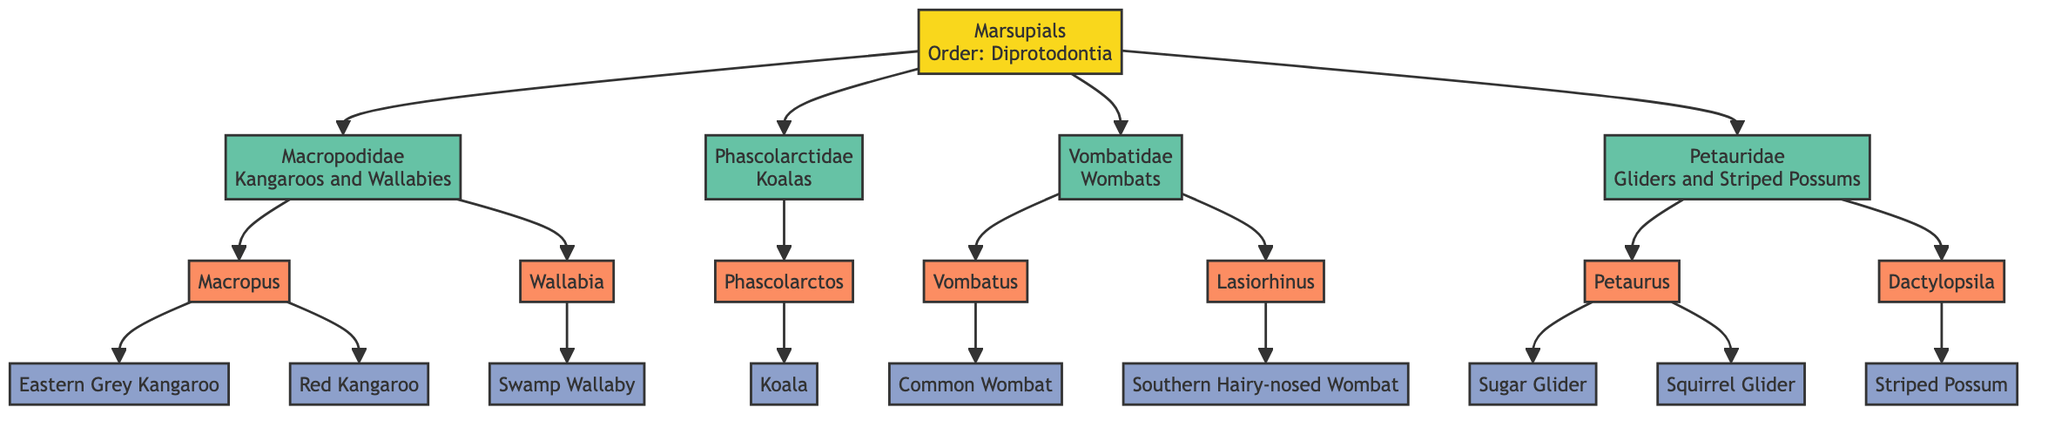What is the order of all the marsupials displayed? The diagram shows a node labeled "Order: Diprotodontia" connected to the Marsupials node. This indicates that all the depicted species belong to this order.
Answer: Diprotodontia How many families are present in the marsupial diagram? By counting the family nodes connected to the Marsupials node, there are four distinct families listed: Macropodidae, Phascolarctidae, Vombatidae, and Petauridae.
Answer: 4 Which family do koalas belong to? The diagram displays a connection from the Phascolarctidae family node to the genus Phascolarctos, which lists "Koala" as a species. Thus, koalas are classified under the Phascolarctidae family.
Answer: Phascolarctidae What are the genera under the Vombatidae family? Looking at the Vombatidae node, it connects to two genera nodes: Vombatus and Lasiorhinus, which are the genera included in this family.
Answer: Vombatus, Lasiorhinus How many species are there within the Petauridae family? The Petauridae family node connects to two genera: Petaurus and Dactylopsila. The Petaurus genus lists "Sugar Glider" and "Squirrel Glider" as its species, while Dactylopsila has "Striped Possum," leading to a total of three species.
Answer: 3 Which species does the Macropus genus contain? Examining the Macropus node in the diagram reveals two species listed: "Eastern Grey Kangaroo" and "Red Kangaroo." Therefore, these are the species that belong to the Macropus genus.
Answer: Eastern Grey Kangaroo, Red Kangaroo Which family has the common name "Gliders and Striped Possums"? The node labeled "Petauridae" includes the common name "Gliders and Striped Possums" per its label, indicating that this family encompasses those animals.
Answer: Petauridae Which genus is associated with the Southern Hairy-nosed Wombat? The diagram shows the Lasiorhinus node connected to the species "Southern Hairy-nosed Wombat," which indicates that this species belongs to the Lasiorhinus genus.
Answer: Lasiorhinus What is the common name for the family Macropodidae? The Macropodidae family node on the diagram explicitly states "Kangaroos and Wallabies" as its common name, indicating the type of animals this family includes.
Answer: Kangaroos and Wallabies 